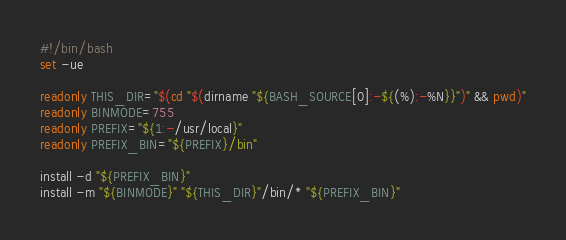Convert code to text. <code><loc_0><loc_0><loc_500><loc_500><_Bash_>#!/bin/bash
set -ue

readonly THIS_DIR="$(cd "$(dirname "${BASH_SOURCE[0]:-${(%):-%N}}")" && pwd)"
readonly BINMODE=755
readonly PREFIX="${1:-/usr/local}"
readonly PREFIX_BIN="${PREFIX}/bin"

install -d "${PREFIX_BIN}"
install -m "${BINMODE}" "${THIS_DIR}"/bin/* "${PREFIX_BIN}"
</code> 